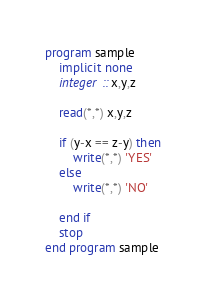<code> <loc_0><loc_0><loc_500><loc_500><_FORTRAN_>program sample
	implicit none
    integer :: x,y,z
    
    read(*,*) x,y,z
    
    if (y-x == z-y) then
    	write(*,*) 'YES'
    else
    	write(*,*) 'NO'
        
    end if
    stop
end program sample</code> 